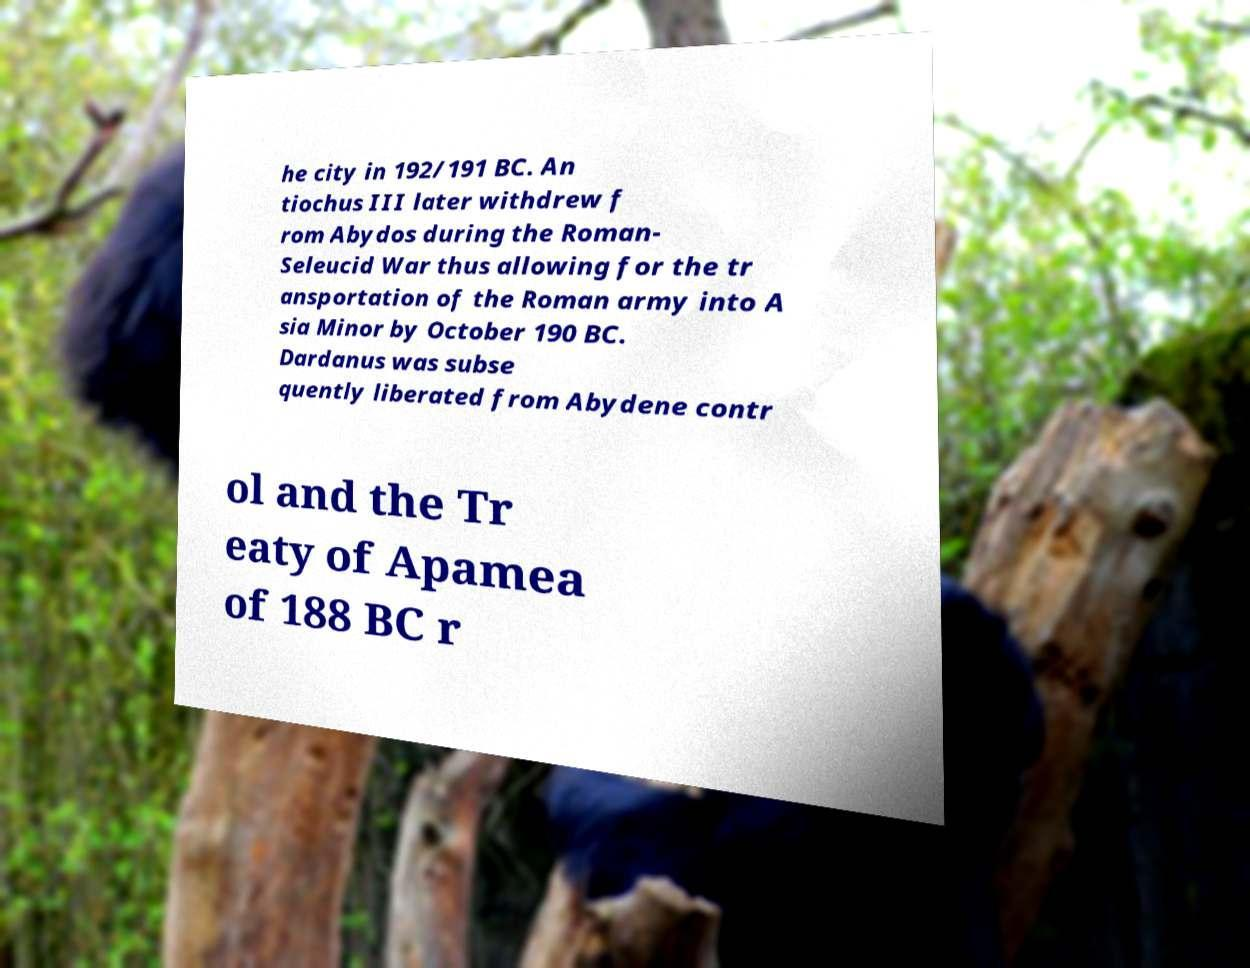There's text embedded in this image that I need extracted. Can you transcribe it verbatim? he city in 192/191 BC. An tiochus III later withdrew f rom Abydos during the Roman- Seleucid War thus allowing for the tr ansportation of the Roman army into A sia Minor by October 190 BC. Dardanus was subse quently liberated from Abydene contr ol and the Tr eaty of Apamea of 188 BC r 